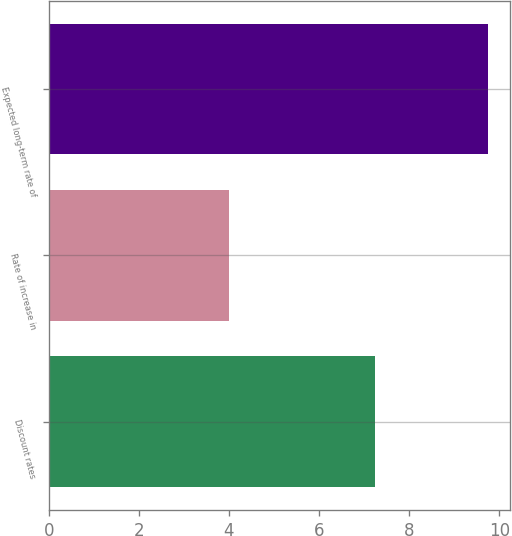<chart> <loc_0><loc_0><loc_500><loc_500><bar_chart><fcel>Discount rates<fcel>Rate of increase in<fcel>Expected long-term rate of<nl><fcel>7.25<fcel>4<fcel>9.75<nl></chart> 